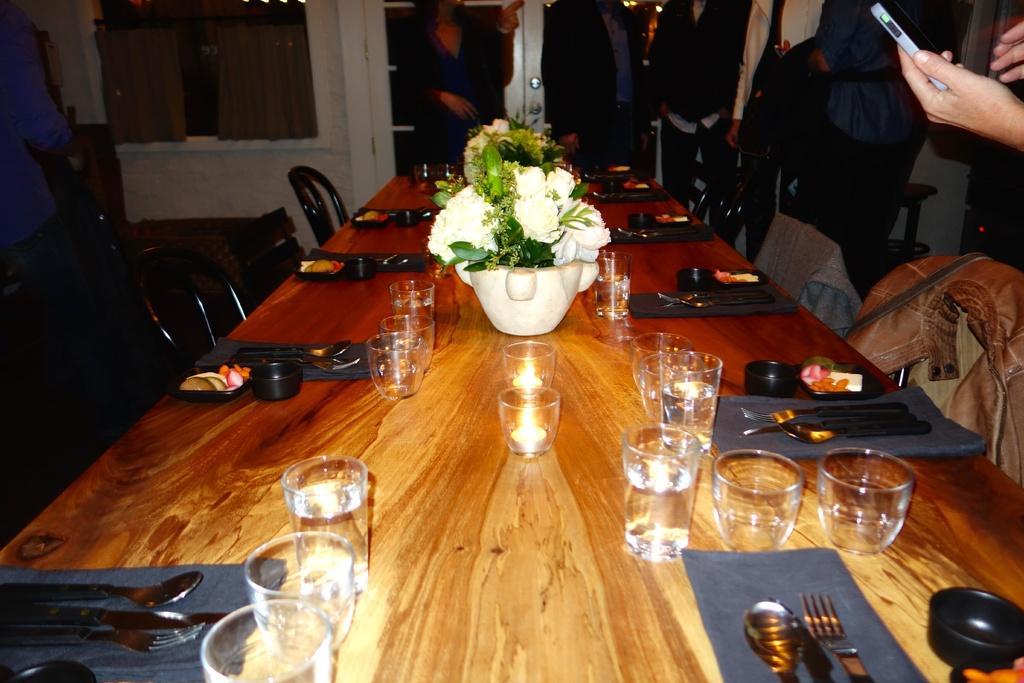Could you give a brief overview of what you see in this image? In this picture we can see a table. On the table there are some glasses, spoons, forks, bowls, and a flower vase. And on the background we can see the wall. These are the chairs, and there is a jacket on the chair. Even we can see some persons are standing on the floor. And this is the door. 